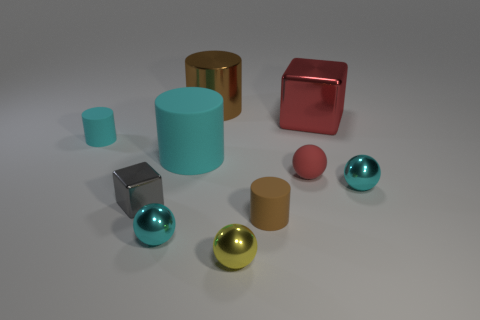What is the color of the metal thing that is behind the tiny cyan matte cylinder and to the left of the red metallic object?
Your response must be concise. Brown. What shape is the yellow metal object that is the same size as the red ball?
Give a very brief answer. Sphere. Is there a cylinder that has the same color as the large cube?
Ensure brevity in your answer.  No. Are there the same number of gray cubes that are behind the tiny red matte sphere and tiny gray matte spheres?
Make the answer very short. Yes. Does the big cube have the same color as the rubber ball?
Your answer should be compact. Yes. There is a cyan object that is behind the red rubber thing and right of the small cyan cylinder; how big is it?
Give a very brief answer. Large. There is a large cylinder that is made of the same material as the small block; what is its color?
Offer a terse response. Brown. How many spheres have the same material as the small gray cube?
Make the answer very short. 3. Is the number of matte spheres that are to the left of the big matte object the same as the number of tiny cyan things to the left of the tiny gray cube?
Your answer should be compact. No. There is a yellow thing; does it have the same shape as the red object in front of the large rubber thing?
Your answer should be compact. Yes. 